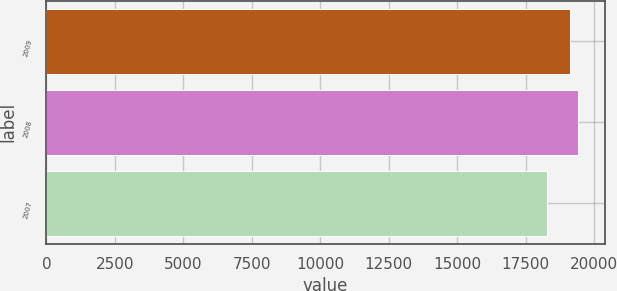Convert chart to OTSL. <chart><loc_0><loc_0><loc_500><loc_500><bar_chart><fcel>2009<fcel>2008<fcel>2007<nl><fcel>19115<fcel>19415<fcel>18266<nl></chart> 